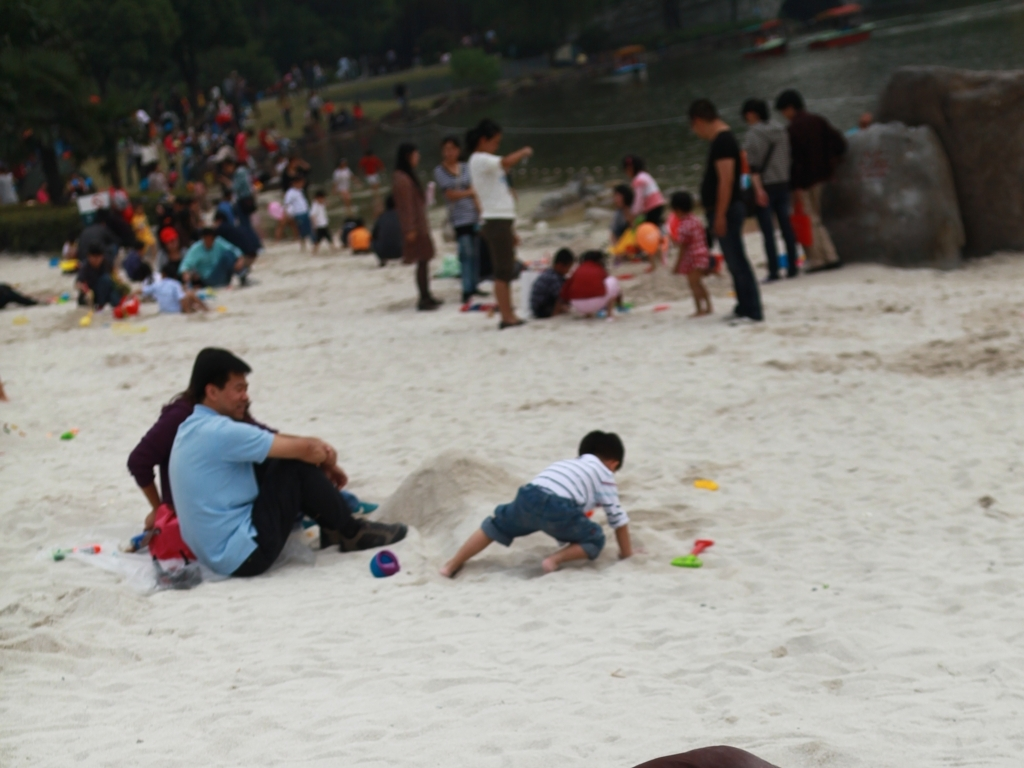Do both the subjects look blurry? The image overall has a low level of sharpness, making the details of both the foreground and background subjects appear blurry. This lack of focus could be intentional for artistic effect or an accidental result of the camera settings. 